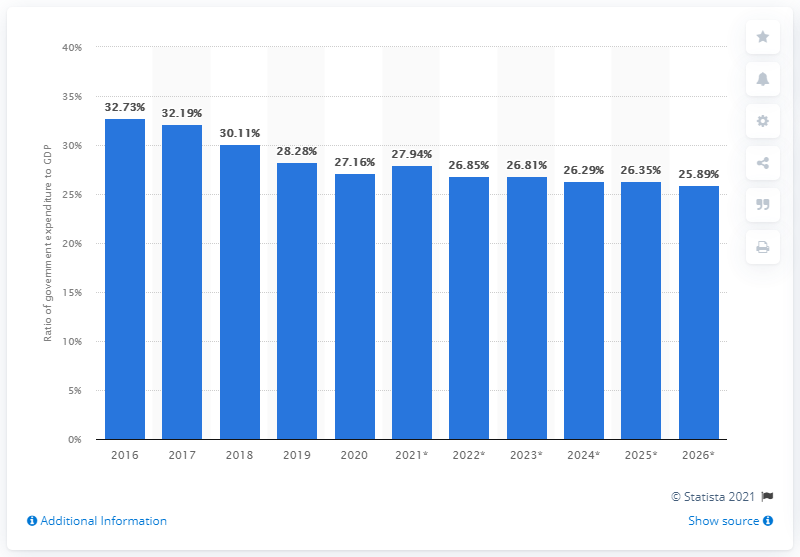Specify some key components in this picture. In 2021, the ratio of national expenditure to GDP was 27.94. 